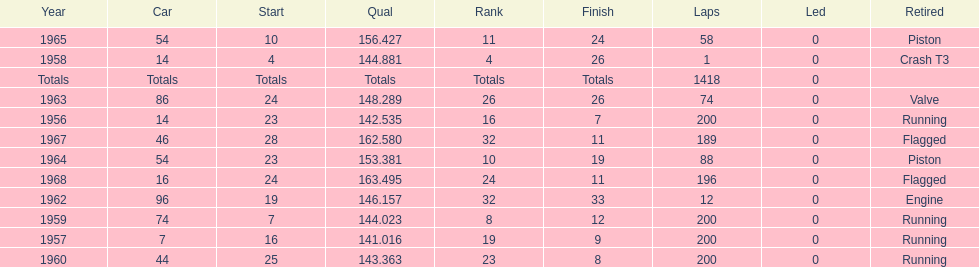How many times was bob veith ranked higher than 10 at an indy 500? 2. 